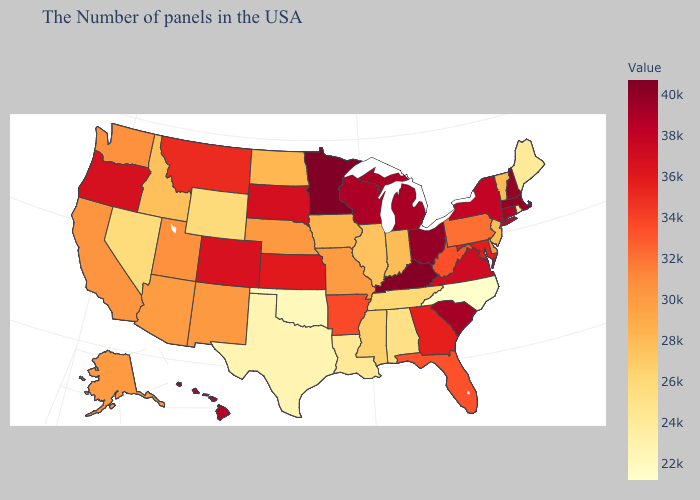Among the states that border Arkansas , does Oklahoma have the lowest value?
Short answer required. Yes. Does Michigan have the lowest value in the USA?
Be succinct. No. Which states have the lowest value in the MidWest?
Answer briefly. Illinois. Does California have the highest value in the West?
Quick response, please. No. 